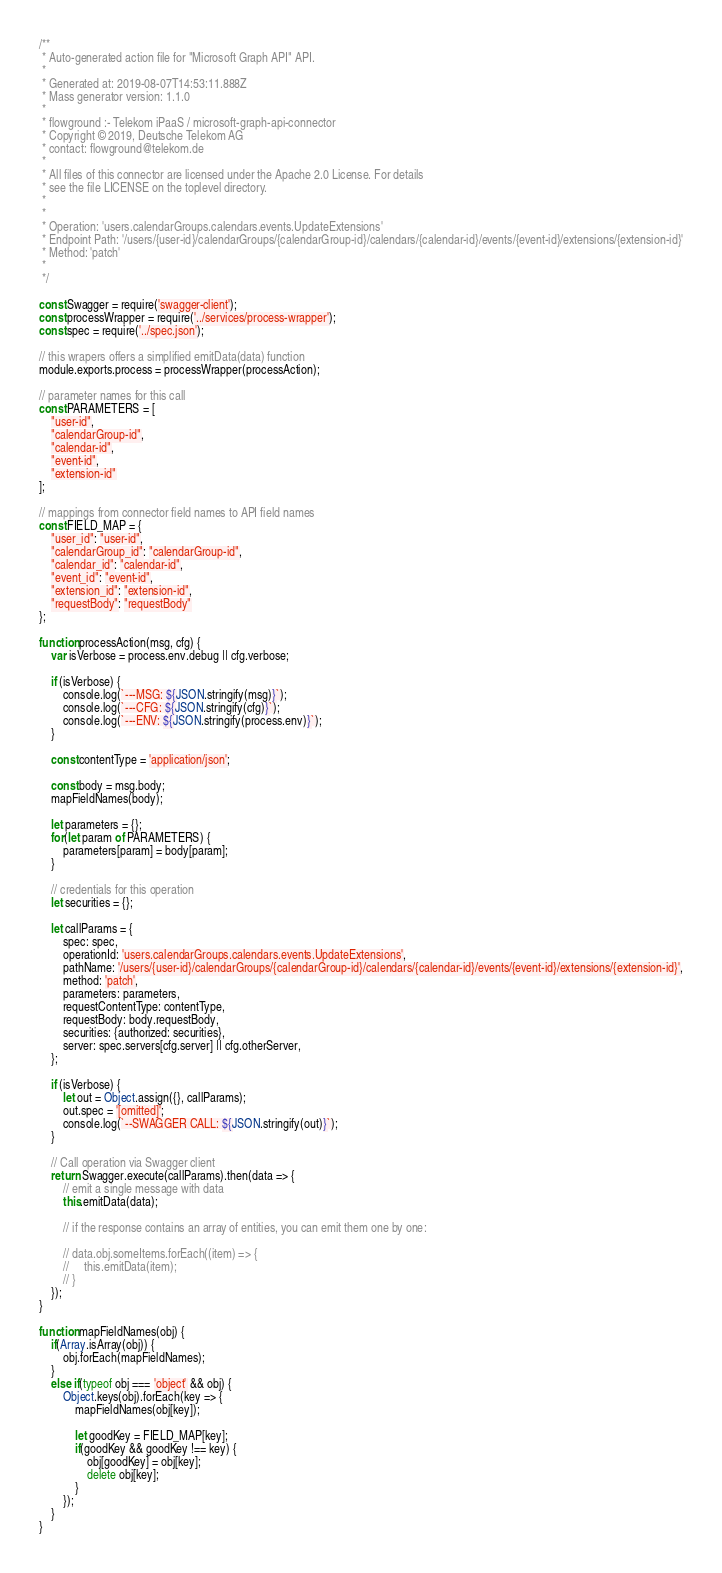<code> <loc_0><loc_0><loc_500><loc_500><_JavaScript_>/**
 * Auto-generated action file for "Microsoft Graph API" API.
 *
 * Generated at: 2019-08-07T14:53:11.888Z
 * Mass generator version: 1.1.0
 *
 * flowground :- Telekom iPaaS / microsoft-graph-api-connector
 * Copyright © 2019, Deutsche Telekom AG
 * contact: flowground@telekom.de
 *
 * All files of this connector are licensed under the Apache 2.0 License. For details
 * see the file LICENSE on the toplevel directory.
 *
 *
 * Operation: 'users.calendarGroups.calendars.events.UpdateExtensions'
 * Endpoint Path: '/users/{user-id}/calendarGroups/{calendarGroup-id}/calendars/{calendar-id}/events/{event-id}/extensions/{extension-id}'
 * Method: 'patch'
 *
 */

const Swagger = require('swagger-client');
const processWrapper = require('../services/process-wrapper');
const spec = require('../spec.json');

// this wrapers offers a simplified emitData(data) function
module.exports.process = processWrapper(processAction);

// parameter names for this call
const PARAMETERS = [
    "user-id",
    "calendarGroup-id",
    "calendar-id",
    "event-id",
    "extension-id"
];

// mappings from connector field names to API field names
const FIELD_MAP = {
    "user_id": "user-id",
    "calendarGroup_id": "calendarGroup-id",
    "calendar_id": "calendar-id",
    "event_id": "event-id",
    "extension_id": "extension-id",
    "requestBody": "requestBody"
};

function processAction(msg, cfg) {
    var isVerbose = process.env.debug || cfg.verbose;

    if (isVerbose) {
        console.log(`---MSG: ${JSON.stringify(msg)}`);
        console.log(`---CFG: ${JSON.stringify(cfg)}`);
        console.log(`---ENV: ${JSON.stringify(process.env)}`);
    }

    const contentType = 'application/json';

    const body = msg.body;
    mapFieldNames(body);

    let parameters = {};
    for(let param of PARAMETERS) {
        parameters[param] = body[param];
    }

    // credentials for this operation
    let securities = {};

    let callParams = {
        spec: spec,
        operationId: 'users.calendarGroups.calendars.events.UpdateExtensions',
        pathName: '/users/{user-id}/calendarGroups/{calendarGroup-id}/calendars/{calendar-id}/events/{event-id}/extensions/{extension-id}',
        method: 'patch',
        parameters: parameters,
        requestContentType: contentType,
        requestBody: body.requestBody,
        securities: {authorized: securities},
        server: spec.servers[cfg.server] || cfg.otherServer,
    };

    if (isVerbose) {
        let out = Object.assign({}, callParams);
        out.spec = '[omitted]';
        console.log(`--SWAGGER CALL: ${JSON.stringify(out)}`);
    }

    // Call operation via Swagger client
    return Swagger.execute(callParams).then(data => {
        // emit a single message with data
        this.emitData(data);

        // if the response contains an array of entities, you can emit them one by one:

        // data.obj.someItems.forEach((item) => {
        //     this.emitData(item);
        // }
    });
}

function mapFieldNames(obj) {
    if(Array.isArray(obj)) {
        obj.forEach(mapFieldNames);
    }
    else if(typeof obj === 'object' && obj) {
        Object.keys(obj).forEach(key => {
            mapFieldNames(obj[key]);

            let goodKey = FIELD_MAP[key];
            if(goodKey && goodKey !== key) {
                obj[goodKey] = obj[key];
                delete obj[key];
            }
        });
    }
}</code> 